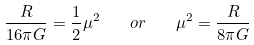Convert formula to latex. <formula><loc_0><loc_0><loc_500><loc_500>\frac { R } { 1 6 \pi G } = \frac { 1 } { 2 } \mu ^ { 2 } \quad o r \quad \mu ^ { 2 } = \frac { R } { 8 \pi G }</formula> 